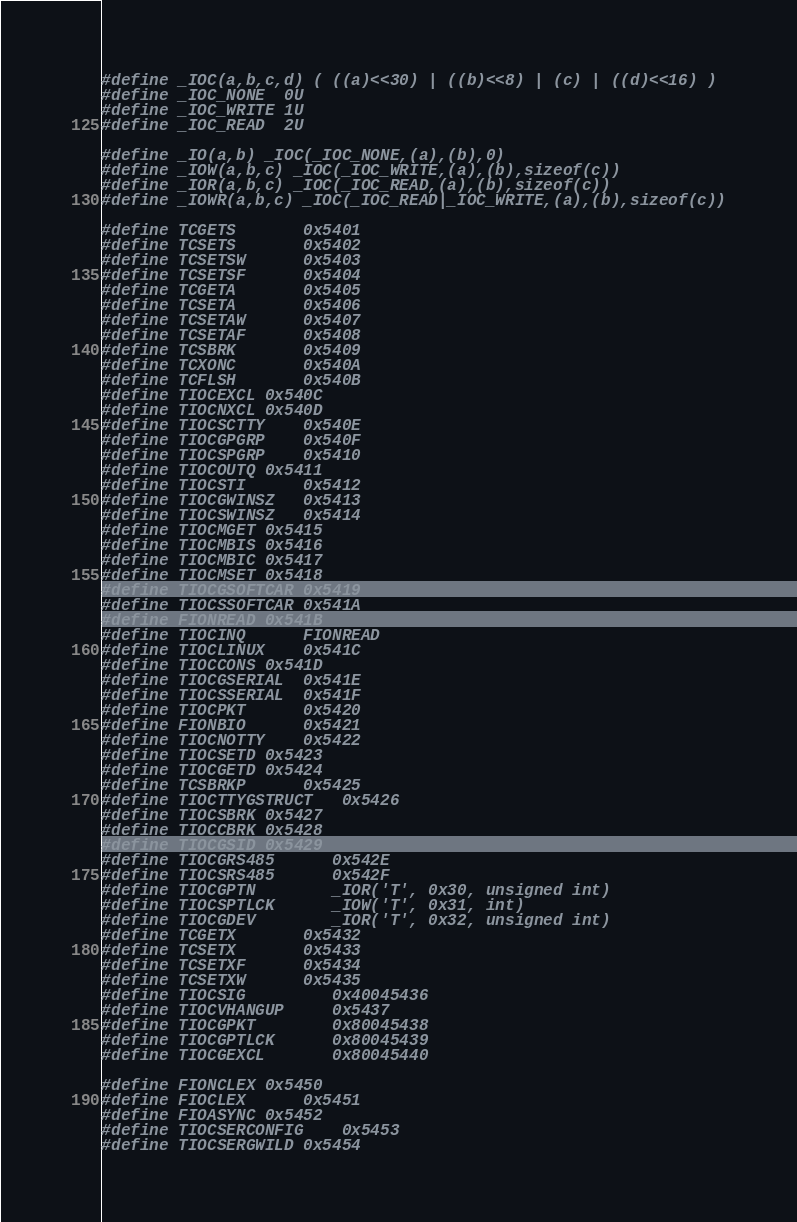<code> <loc_0><loc_0><loc_500><loc_500><_C_>#define _IOC(a,b,c,d) ( ((a)<<30) | ((b)<<8) | (c) | ((d)<<16) )
#define _IOC_NONE  0U
#define _IOC_WRITE 1U
#define _IOC_READ  2U

#define _IO(a,b) _IOC(_IOC_NONE,(a),(b),0)
#define _IOW(a,b,c) _IOC(_IOC_WRITE,(a),(b),sizeof(c))
#define _IOR(a,b,c) _IOC(_IOC_READ,(a),(b),sizeof(c))
#define _IOWR(a,b,c) _IOC(_IOC_READ|_IOC_WRITE,(a),(b),sizeof(c))

#define TCGETS		0x5401
#define TCSETS		0x5402
#define TCSETSW		0x5403
#define TCSETSF		0x5404
#define TCGETA		0x5405
#define TCSETA		0x5406
#define TCSETAW		0x5407
#define TCSETAF		0x5408
#define TCSBRK		0x5409
#define TCXONC		0x540A
#define TCFLSH		0x540B
#define TIOCEXCL	0x540C
#define TIOCNXCL	0x540D
#define TIOCSCTTY	0x540E
#define TIOCGPGRP	0x540F
#define TIOCSPGRP	0x5410
#define TIOCOUTQ	0x5411
#define TIOCSTI		0x5412
#define TIOCGWINSZ	0x5413
#define TIOCSWINSZ	0x5414
#define TIOCMGET	0x5415
#define TIOCMBIS	0x5416
#define TIOCMBIC	0x5417
#define TIOCMSET	0x5418
#define TIOCGSOFTCAR	0x5419
#define TIOCSSOFTCAR	0x541A
#define FIONREAD	0x541B
#define TIOCINQ		FIONREAD
#define TIOCLINUX	0x541C
#define TIOCCONS	0x541D
#define TIOCGSERIAL	0x541E
#define TIOCSSERIAL	0x541F
#define TIOCPKT		0x5420
#define FIONBIO		0x5421
#define TIOCNOTTY	0x5422
#define TIOCSETD	0x5423
#define TIOCGETD	0x5424
#define TCSBRKP		0x5425
#define TIOCTTYGSTRUCT	0x5426
#define TIOCSBRK	0x5427
#define TIOCCBRK	0x5428
#define TIOCGSID	0x5429
#define TIOCGRS485      0x542E
#define TIOCSRS485      0x542F
#define TIOCGPTN        _IOR('T', 0x30, unsigned int)
#define TIOCSPTLCK      _IOW('T', 0x31, int)
#define TIOCGDEV        _IOR('T', 0x32, unsigned int)
#define TCGETX		0x5432
#define TCSETX		0x5433
#define TCSETXF		0x5434
#define TCSETXW		0x5435
#define TIOCSIG         0x40045436
#define TIOCVHANGUP     0x5437
#define TIOCGPKT        0x80045438
#define TIOCGPTLCK      0x80045439
#define TIOCGEXCL       0x80045440

#define FIONCLEX	0x5450
#define FIOCLEX		0x5451
#define FIOASYNC	0x5452
#define TIOCSERCONFIG	0x5453
#define TIOCSERGWILD	0x5454</code> 